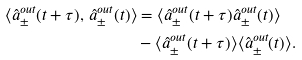<formula> <loc_0><loc_0><loc_500><loc_500>\langle \hat { a } ^ { o u t } _ { \pm } ( t + \tau ) , \, \hat { a } ^ { o u t } _ { \pm } ( t ) \rangle & = \langle \hat { a } ^ { o u t } _ { \pm } ( t + \tau ) \hat { a } ^ { o u t } _ { \pm } ( t ) \rangle \\ & - \langle \hat { a } ^ { o u t } _ { \pm } ( t + \tau ) \rangle \langle \hat { a } ^ { o u t } _ { \pm } ( t ) \rangle .</formula> 